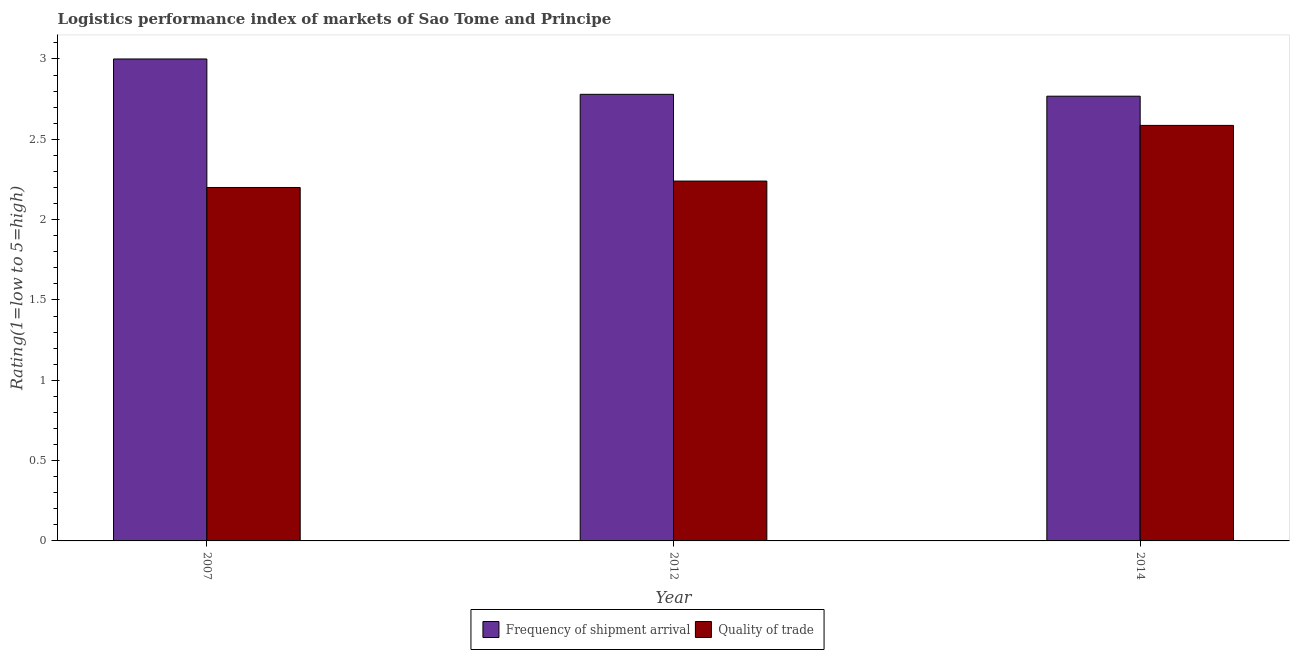How many bars are there on the 2nd tick from the left?
Offer a terse response. 2. How many bars are there on the 2nd tick from the right?
Offer a very short reply. 2. What is the lpi quality of trade in 2012?
Give a very brief answer. 2.24. In which year was the lpi quality of trade maximum?
Ensure brevity in your answer.  2014. What is the total lpi of frequency of shipment arrival in the graph?
Provide a succinct answer. 8.55. What is the difference between the lpi of frequency of shipment arrival in 2007 and that in 2014?
Offer a terse response. 0.23. What is the difference between the lpi of frequency of shipment arrival in 2012 and the lpi quality of trade in 2014?
Your answer should be very brief. 0.01. What is the average lpi quality of trade per year?
Give a very brief answer. 2.34. What is the ratio of the lpi of frequency of shipment arrival in 2007 to that in 2012?
Keep it short and to the point. 1.08. Is the lpi of frequency of shipment arrival in 2012 less than that in 2014?
Provide a succinct answer. No. What is the difference between the highest and the second highest lpi of frequency of shipment arrival?
Your response must be concise. 0.22. What is the difference between the highest and the lowest lpi quality of trade?
Your response must be concise. 0.39. What does the 2nd bar from the left in 2007 represents?
Make the answer very short. Quality of trade. What does the 1st bar from the right in 2014 represents?
Ensure brevity in your answer.  Quality of trade. How many years are there in the graph?
Your answer should be compact. 3. Does the graph contain any zero values?
Provide a short and direct response. No. Does the graph contain grids?
Your answer should be compact. No. Where does the legend appear in the graph?
Offer a very short reply. Bottom center. What is the title of the graph?
Your response must be concise. Logistics performance index of markets of Sao Tome and Principe. Does "Time to import" appear as one of the legend labels in the graph?
Offer a terse response. No. What is the label or title of the Y-axis?
Your answer should be compact. Rating(1=low to 5=high). What is the Rating(1=low to 5=high) of Frequency of shipment arrival in 2007?
Make the answer very short. 3. What is the Rating(1=low to 5=high) of Frequency of shipment arrival in 2012?
Your answer should be compact. 2.78. What is the Rating(1=low to 5=high) in Quality of trade in 2012?
Your response must be concise. 2.24. What is the Rating(1=low to 5=high) in Frequency of shipment arrival in 2014?
Your answer should be very brief. 2.77. What is the Rating(1=low to 5=high) in Quality of trade in 2014?
Your answer should be very brief. 2.59. Across all years, what is the maximum Rating(1=low to 5=high) in Frequency of shipment arrival?
Offer a terse response. 3. Across all years, what is the maximum Rating(1=low to 5=high) of Quality of trade?
Make the answer very short. 2.59. Across all years, what is the minimum Rating(1=low to 5=high) of Frequency of shipment arrival?
Keep it short and to the point. 2.77. Across all years, what is the minimum Rating(1=low to 5=high) in Quality of trade?
Ensure brevity in your answer.  2.2. What is the total Rating(1=low to 5=high) in Frequency of shipment arrival in the graph?
Make the answer very short. 8.55. What is the total Rating(1=low to 5=high) in Quality of trade in the graph?
Give a very brief answer. 7.03. What is the difference between the Rating(1=low to 5=high) in Frequency of shipment arrival in 2007 and that in 2012?
Ensure brevity in your answer.  0.22. What is the difference between the Rating(1=low to 5=high) of Quality of trade in 2007 and that in 2012?
Your answer should be compact. -0.04. What is the difference between the Rating(1=low to 5=high) of Frequency of shipment arrival in 2007 and that in 2014?
Provide a short and direct response. 0.23. What is the difference between the Rating(1=low to 5=high) of Quality of trade in 2007 and that in 2014?
Provide a short and direct response. -0.39. What is the difference between the Rating(1=low to 5=high) in Frequency of shipment arrival in 2012 and that in 2014?
Your answer should be compact. 0.01. What is the difference between the Rating(1=low to 5=high) in Quality of trade in 2012 and that in 2014?
Your answer should be compact. -0.35. What is the difference between the Rating(1=low to 5=high) of Frequency of shipment arrival in 2007 and the Rating(1=low to 5=high) of Quality of trade in 2012?
Your response must be concise. 0.76. What is the difference between the Rating(1=low to 5=high) in Frequency of shipment arrival in 2007 and the Rating(1=low to 5=high) in Quality of trade in 2014?
Provide a short and direct response. 0.41. What is the difference between the Rating(1=low to 5=high) of Frequency of shipment arrival in 2012 and the Rating(1=low to 5=high) of Quality of trade in 2014?
Offer a very short reply. 0.19. What is the average Rating(1=low to 5=high) of Frequency of shipment arrival per year?
Make the answer very short. 2.85. What is the average Rating(1=low to 5=high) in Quality of trade per year?
Provide a succinct answer. 2.34. In the year 2012, what is the difference between the Rating(1=low to 5=high) in Frequency of shipment arrival and Rating(1=low to 5=high) in Quality of trade?
Provide a succinct answer. 0.54. In the year 2014, what is the difference between the Rating(1=low to 5=high) in Frequency of shipment arrival and Rating(1=low to 5=high) in Quality of trade?
Your answer should be very brief. 0.18. What is the ratio of the Rating(1=low to 5=high) in Frequency of shipment arrival in 2007 to that in 2012?
Keep it short and to the point. 1.08. What is the ratio of the Rating(1=low to 5=high) in Quality of trade in 2007 to that in 2012?
Your answer should be compact. 0.98. What is the ratio of the Rating(1=low to 5=high) of Frequency of shipment arrival in 2007 to that in 2014?
Give a very brief answer. 1.08. What is the ratio of the Rating(1=low to 5=high) in Quality of trade in 2007 to that in 2014?
Offer a very short reply. 0.85. What is the ratio of the Rating(1=low to 5=high) of Quality of trade in 2012 to that in 2014?
Provide a short and direct response. 0.87. What is the difference between the highest and the second highest Rating(1=low to 5=high) in Frequency of shipment arrival?
Your response must be concise. 0.22. What is the difference between the highest and the second highest Rating(1=low to 5=high) of Quality of trade?
Provide a succinct answer. 0.35. What is the difference between the highest and the lowest Rating(1=low to 5=high) in Frequency of shipment arrival?
Your answer should be compact. 0.23. What is the difference between the highest and the lowest Rating(1=low to 5=high) in Quality of trade?
Your answer should be compact. 0.39. 